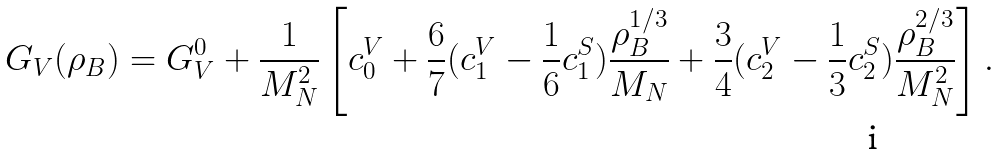Convert formula to latex. <formula><loc_0><loc_0><loc_500><loc_500>G _ { V } ( \rho _ { B } ) = G _ { V } ^ { 0 } + \frac { 1 } { M _ { N } ^ { 2 } } \left [ c _ { 0 } ^ { V } + \frac { 6 } { 7 } ( c _ { 1 } ^ { V } - \frac { 1 } { 6 } c _ { 1 } ^ { S } ) \frac { \rho _ { B } ^ { 1 / 3 } } { M _ { N } } + \frac { 3 } { 4 } ( c _ { 2 } ^ { V } - \frac { 1 } { 3 } c _ { 2 } ^ { S } ) \frac { \rho _ { B } ^ { 2 / 3 } } { M _ { N } ^ { 2 } } \right ] .</formula> 